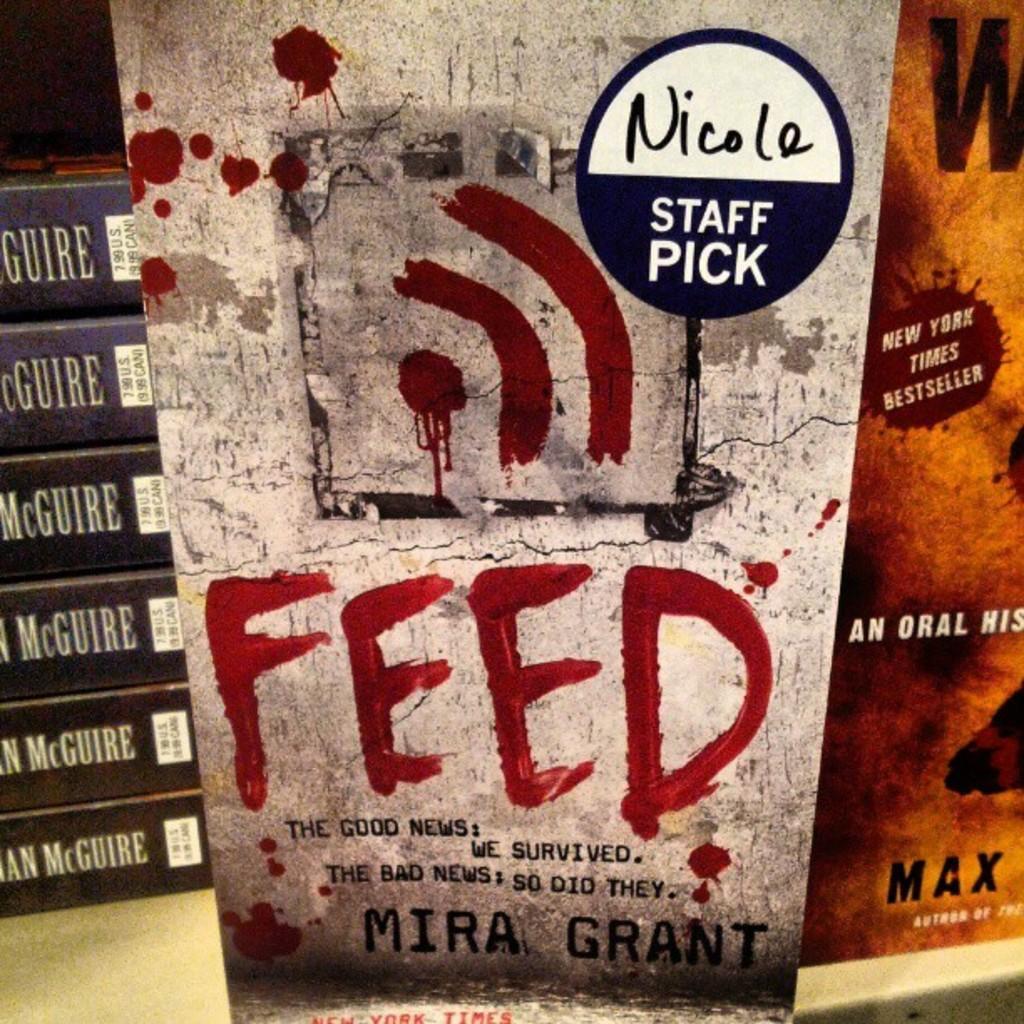Can you describe this image briefly? In the center of the image there is a book for staff and to the left there are six books on the surface. In the right there is an orange color book. 